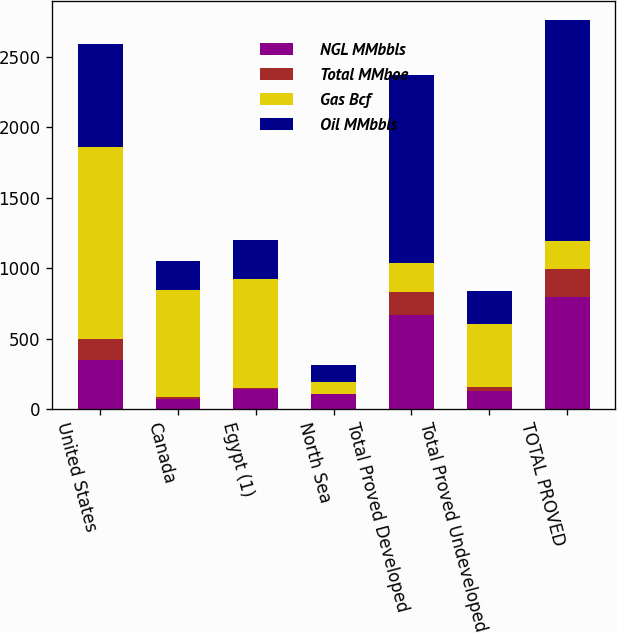Convert chart to OTSL. <chart><loc_0><loc_0><loc_500><loc_500><stacked_bar_chart><ecel><fcel>United States<fcel>Canada<fcel>Egypt (1)<fcel>North Sea<fcel>Total Proved Developed<fcel>Total Proved Undeveloped<fcel>TOTAL PROVED<nl><fcel>NGL MMbbls<fcel>349<fcel>68<fcel>144<fcel>105<fcel>666<fcel>128<fcel>794<nl><fcel>Total MMboe<fcel>150<fcel>15<fcel>2<fcel>1<fcel>168<fcel>30<fcel>198<nl><fcel>Gas Bcf<fcel>1364<fcel>759<fcel>776<fcel>86<fcel>204<fcel>445<fcel>204<nl><fcel>Oil MMbbls<fcel>727<fcel>210<fcel>275<fcel>120<fcel>1332<fcel>232<fcel>1564<nl></chart> 